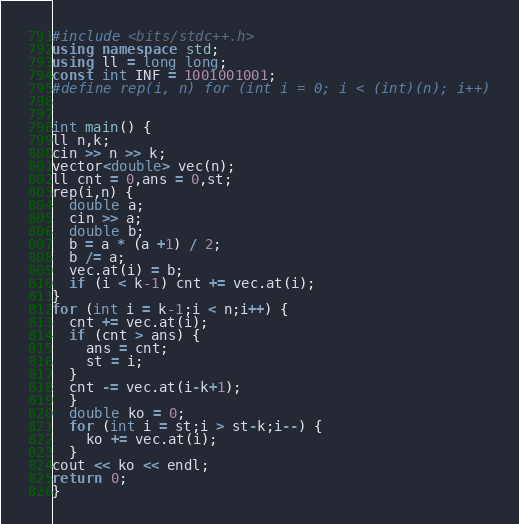Convert code to text. <code><loc_0><loc_0><loc_500><loc_500><_C++_>#include <bits/stdc++.h>
using namespace std;
using ll = long long;
const int INF = 1001001001;
#define rep(i, n) for (int i = 0; i < (int)(n); i++)


int main() {
ll n,k;
cin >> n >> k;
vector<double> vec(n);
ll cnt = 0,ans = 0,st;
rep(i,n) {
  double a;
  cin >> a;
  double b;
  b = a * (a +1) / 2;
  b /= a;
  vec.at(i) = b;
  if (i < k-1) cnt += vec.at(i);
}
for (int i = k-1;i < n;i++) {
  cnt += vec.at(i);
  if (cnt > ans) {
    ans = cnt;
    st = i;
  }
  cnt -= vec.at(i-k+1);
  }
  double ko = 0;
  for (int i = st;i > st-k;i--) {
    ko += vec.at(i);
  }
cout << ko << endl;
return 0;
}

</code> 